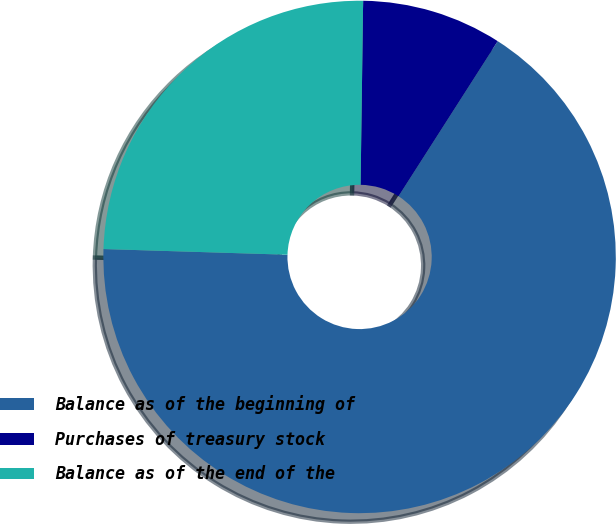<chart> <loc_0><loc_0><loc_500><loc_500><pie_chart><fcel>Balance as of the beginning of<fcel>Purchases of treasury stock<fcel>Balance as of the end of the<nl><fcel>66.43%<fcel>8.84%<fcel>24.73%<nl></chart> 